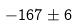<formula> <loc_0><loc_0><loc_500><loc_500>- 1 6 7 \pm 6</formula> 